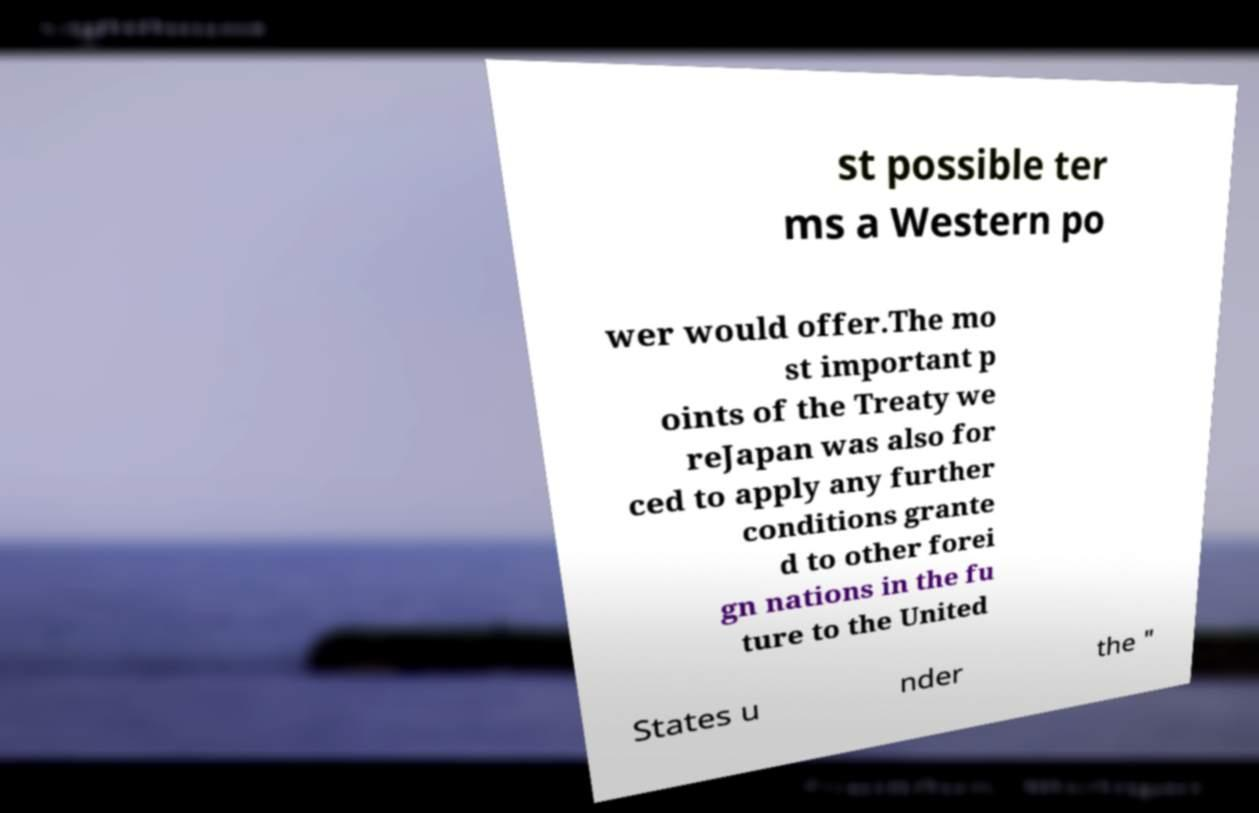What messages or text are displayed in this image? I need them in a readable, typed format. st possible ter ms a Western po wer would offer.The mo st important p oints of the Treaty we reJapan was also for ced to apply any further conditions grante d to other forei gn nations in the fu ture to the United States u nder the " 